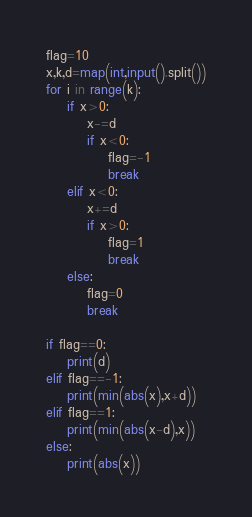<code> <loc_0><loc_0><loc_500><loc_500><_Python_>flag=10
x,k,d=map(int,input().split())
for i in range(k):
    if x>0:
        x-=d
        if x<0:
            flag=-1
            break
    elif x<0:
        x+=d
        if x>0:
            flag=1
            break
    else:
        flag=0
        break

if flag==0:
    print(d)
elif flag==-1:
    print(min(abs(x),x+d))
elif flag==1:
    print(min(abs(x-d),x))
else:
    print(abs(x))
</code> 